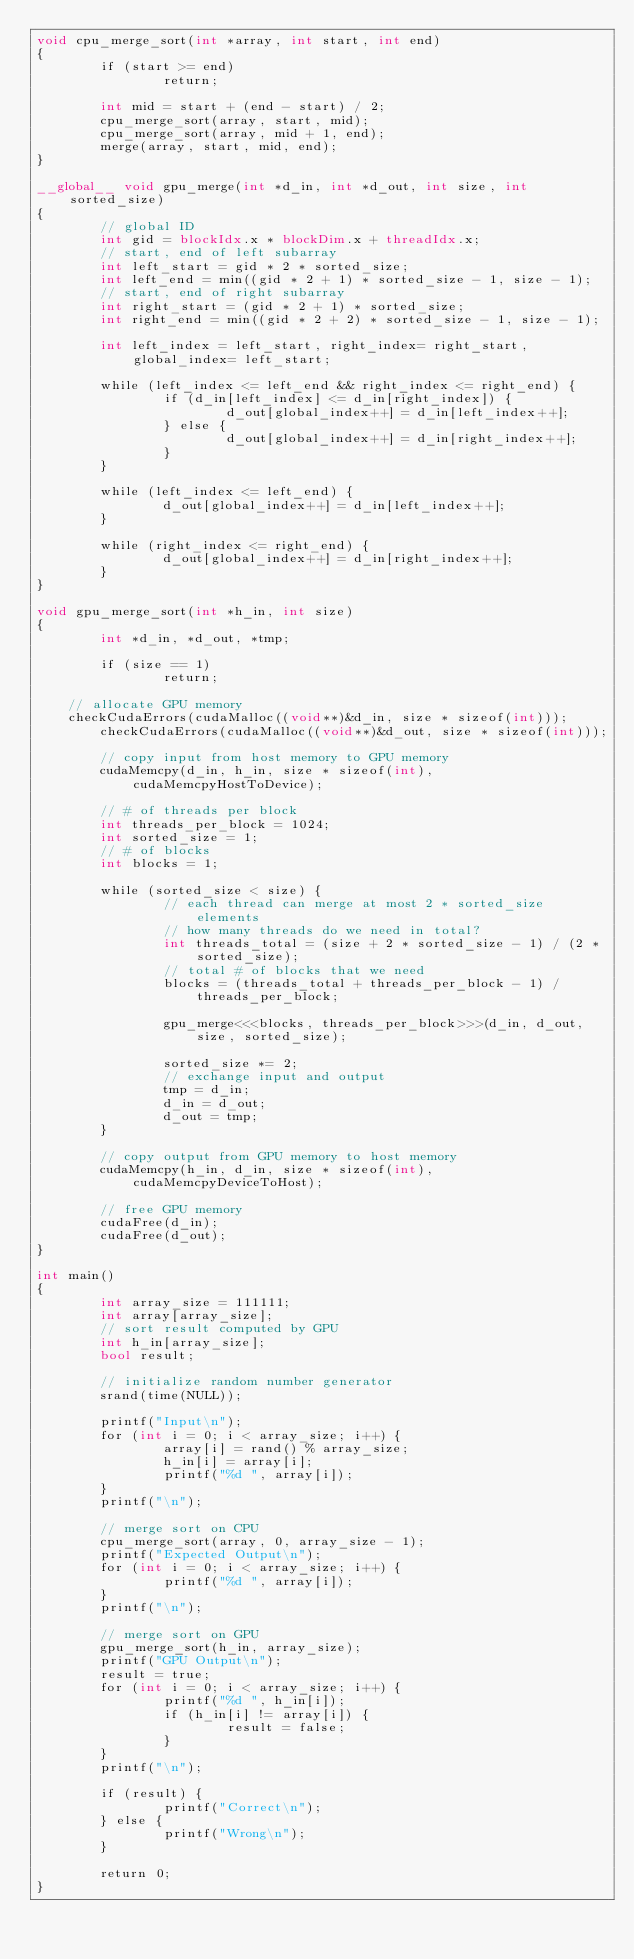<code> <loc_0><loc_0><loc_500><loc_500><_Cuda_>void cpu_merge_sort(int *array, int start, int end)
{
        if (start >= end)
                return;
        
        int mid = start + (end - start) / 2;
        cpu_merge_sort(array, start, mid);
        cpu_merge_sort(array, mid + 1, end);
        merge(array, start, mid, end);
}

__global__ void gpu_merge(int *d_in, int *d_out, int size, int sorted_size) 
{
        // global ID
        int gid = blockIdx.x * blockDim.x + threadIdx.x;
        // start, end of left subarray
        int left_start = gid * 2 * sorted_size;
        int left_end = min((gid * 2 + 1) * sorted_size - 1, size - 1);
        // start, end of right subarray
        int right_start = (gid * 2 + 1) * sorted_size;
        int right_end = min((gid * 2 + 2) * sorted_size - 1, size - 1);
        
        int left_index = left_start, right_index= right_start, global_index= left_start;

        while (left_index <= left_end && right_index <= right_end) {
                if (d_in[left_index] <= d_in[right_index]) {
                        d_out[global_index++] = d_in[left_index++];
                } else {
                        d_out[global_index++] = d_in[right_index++];                        
                }
        }

        while (left_index <= left_end) {
                d_out[global_index++] = d_in[left_index++];                
        }

        while (right_index <= right_end) {
                d_out[global_index++] = d_in[right_index++];                  
        }
}

void gpu_merge_sort(int *h_in, int size)
{
        int *d_in, *d_out, *tmp;

        if (size == 1)
                return;
        
	// allocate GPU memory
	checkCudaErrors(cudaMalloc((void**)&d_in, size * sizeof(int)));
        checkCudaErrors(cudaMalloc((void**)&d_out, size * sizeof(int)));

        // copy input from host memory to GPU memory
        cudaMemcpy(d_in, h_in, size * sizeof(int), cudaMemcpyHostToDevice);

        // # of threads per block
        int threads_per_block = 1024;
        int sorted_size = 1;
        // # of blocks 
        int blocks = 1;

        while (sorted_size < size) {
                // each thread can merge at most 2 * sorted_size elements
                // how many threads do we need in total?
                int threads_total = (size + 2 * sorted_size - 1) / (2 * sorted_size);
                // total # of blocks that we need
                blocks = (threads_total + threads_per_block - 1) / threads_per_block;

                gpu_merge<<<blocks, threads_per_block>>>(d_in, d_out, size, sorted_size);
                
                sorted_size *= 2;
                // exchange input and output
                tmp = d_in;
                d_in = d_out;
                d_out = tmp;
        }

        // copy output from GPU memory to host memory
        cudaMemcpy(h_in, d_in, size * sizeof(int), cudaMemcpyDeviceToHost);

        // free GPU memory
        cudaFree(d_in);
        cudaFree(d_out);
}

int main()
{
        int array_size = 111111;
        int array[array_size];
        // sort result computed by GPU
        int h_in[array_size];
        bool result;

        // initialize random number generator
        srand(time(NULL));

        printf("Input\n");
        for (int i = 0; i < array_size; i++) {
                array[i] = rand() % array_size;
                h_in[i] = array[i];
                printf("%d ", array[i]);
        }
        printf("\n");

        // merge sort on CPU
        cpu_merge_sort(array, 0, array_size - 1);
        printf("Expected Output\n");
        for (int i = 0; i < array_size; i++) {
                printf("%d ", array[i]);
        }         
        printf("\n");        
        
        // merge sort on GPU
        gpu_merge_sort(h_in, array_size);
        printf("GPU Output\n"); 
        result = true;
        for (int i = 0; i < array_size; i++) {
                printf("%d ", h_in[i]);
                if (h_in[i] != array[i]) {
                        result = false;
                }
        }        
        printf("\n");

        if (result) {
                printf("Correct\n");
        } else {
                printf("Wrong\n");
        }
        
        return 0;
}</code> 